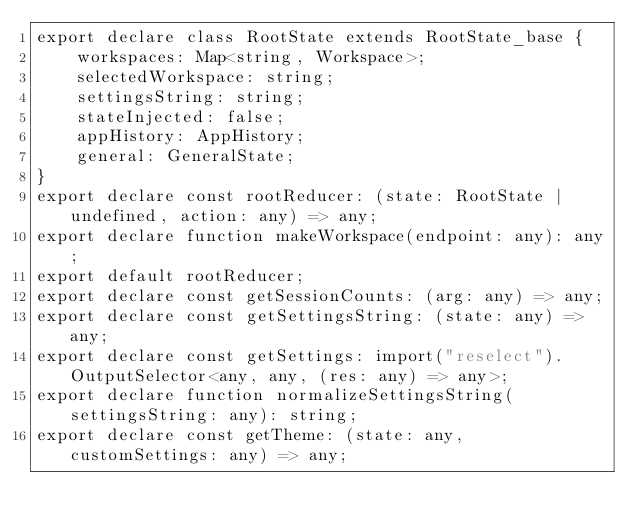Convert code to text. <code><loc_0><loc_0><loc_500><loc_500><_TypeScript_>export declare class RootState extends RootState_base {
    workspaces: Map<string, Workspace>;
    selectedWorkspace: string;
    settingsString: string;
    stateInjected: false;
    appHistory: AppHistory;
    general: GeneralState;
}
export declare const rootReducer: (state: RootState | undefined, action: any) => any;
export declare function makeWorkspace(endpoint: any): any;
export default rootReducer;
export declare const getSessionCounts: (arg: any) => any;
export declare const getSettingsString: (state: any) => any;
export declare const getSettings: import("reselect").OutputSelector<any, any, (res: any) => any>;
export declare function normalizeSettingsString(settingsString: any): string;
export declare const getTheme: (state: any, customSettings: any) => any;
</code> 